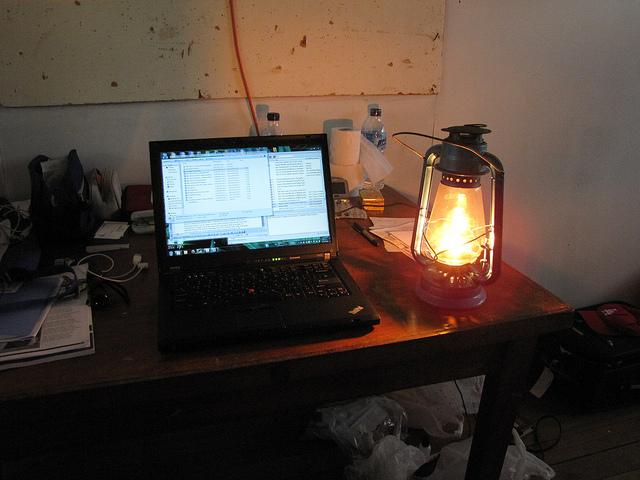What type of light source is next to the laptop?

Choices:
A) chandelier
B) lantern
C) sunlight
D) lamp lantern 